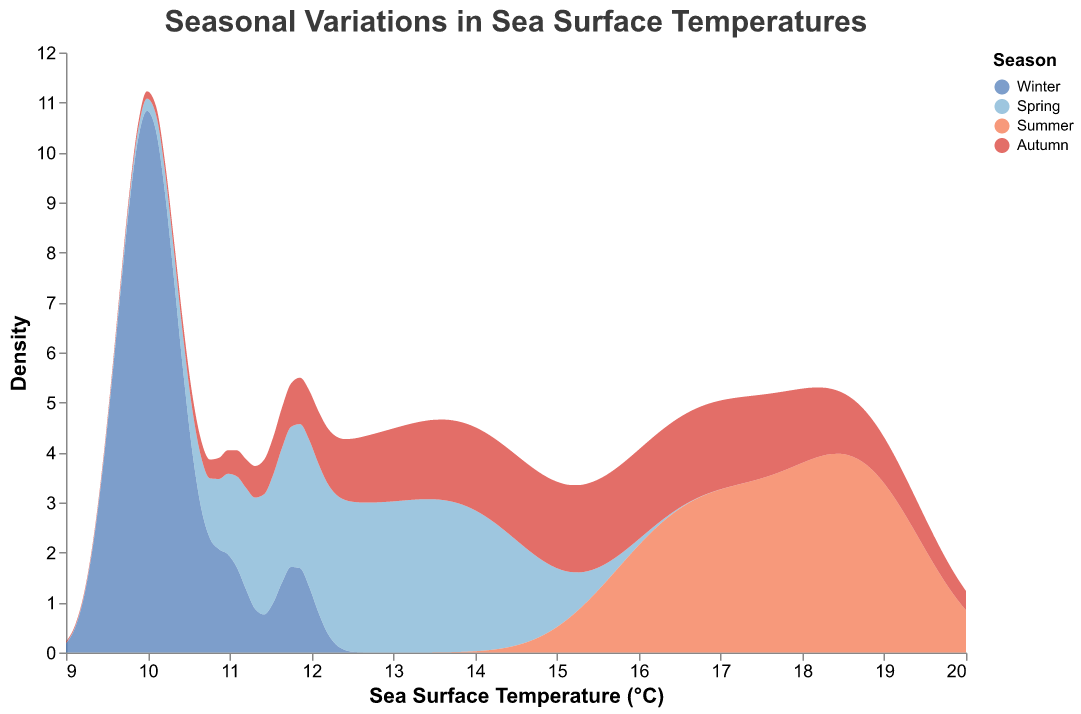What is the title of the figure? The title of the figure is the text at the top of the chart.
Answer: Seasonal Variations in Sea Surface Temperatures Which season has the highest peak in sea surface temperature? The colored areas represent different seasons. The tallest peak among them is observed in the 'Summer' area.
Answer: Summer What is the range of sea surface temperatures displayed? The x-axis indicates the sea surface temperature scale, which ranges from approximately 9°C to 20°C.
Answer: 9°C to 20°C How does the density of sea surface temperatures in Winter compare to Summer at 10°C? At the 10°C mark, the density for Winter (blue) is significantly higher than that for Summer (orange).
Answer: Higher Which season shows the highest variability in sea surface temperatures? Variability can be inferred from the spread of the density plot. Summer shows the widest spread across temperatures.
Answer: Summer What is the approximate sea surface temperature where Spring peaks? The peak for Spring (light blue) occurs around 14°C.
Answer: 14°C Compare the peak sea surface temperature density between Autumn and Winter. By looking at the highest points of both distributions, Winter has a higher peak density than Autumn.
Answer: Winter During which season does sea surface temperature exceed 18°C? The highest temperatures, exceeding 18°C, are found in the Summer (orange).
Answer: Summer What is the density of sea surface temperature at 12°C for Autumn? At 12°C, the density for Autumn (red) reaches its approximate peak.
Answer: High Which two seasons have overlapping temperature ranges, and what is the common range? Both Autumn and Winter have overlapping temperatures in the range of 10°C to around 12.5°C.
Answer: 10°C to 12.5°C 